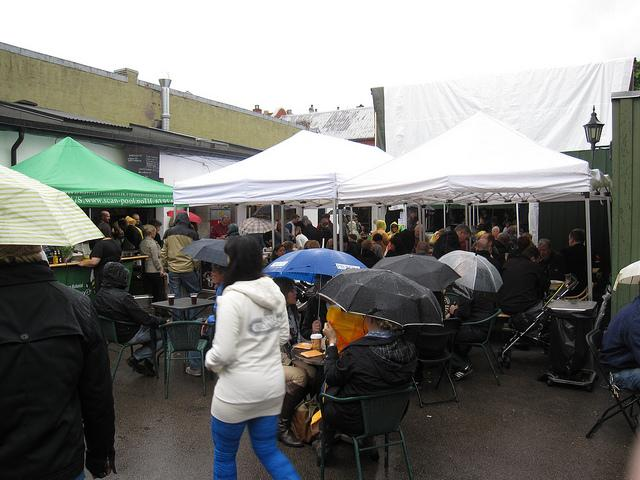Why is the outdoor area using covered gazebos? Please explain your reasoning. stay dry. The sky is very overcast and people also have umbrellas 